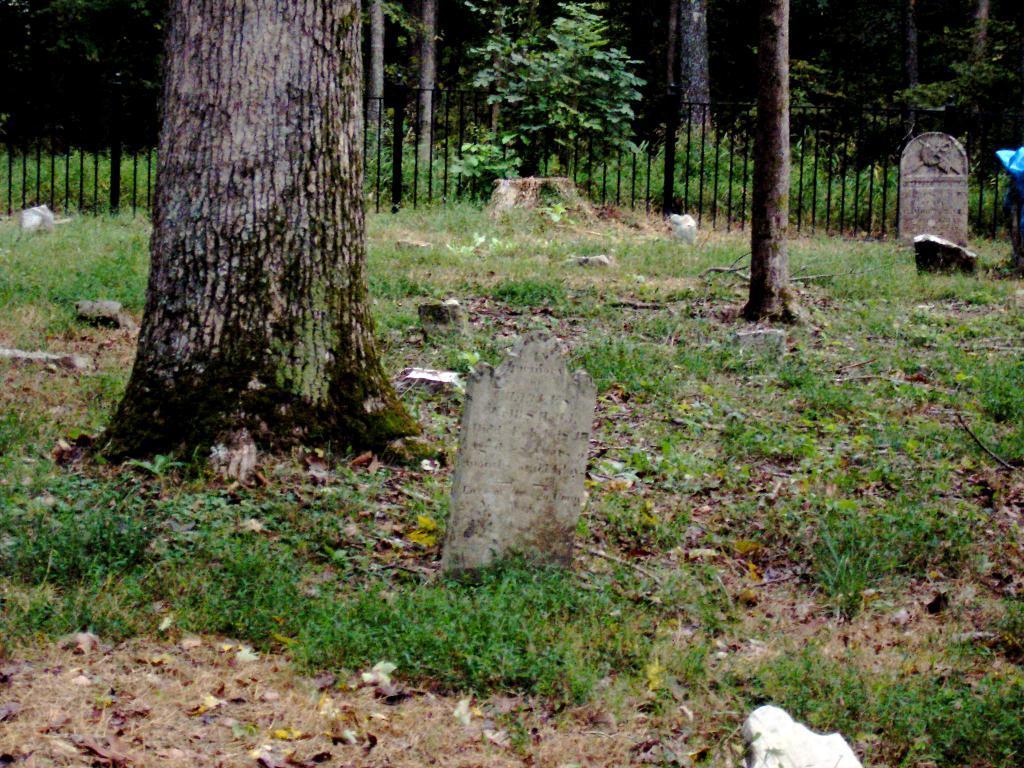Can you describe this image briefly? In this picture we can see grass, walls, fence and trees. 